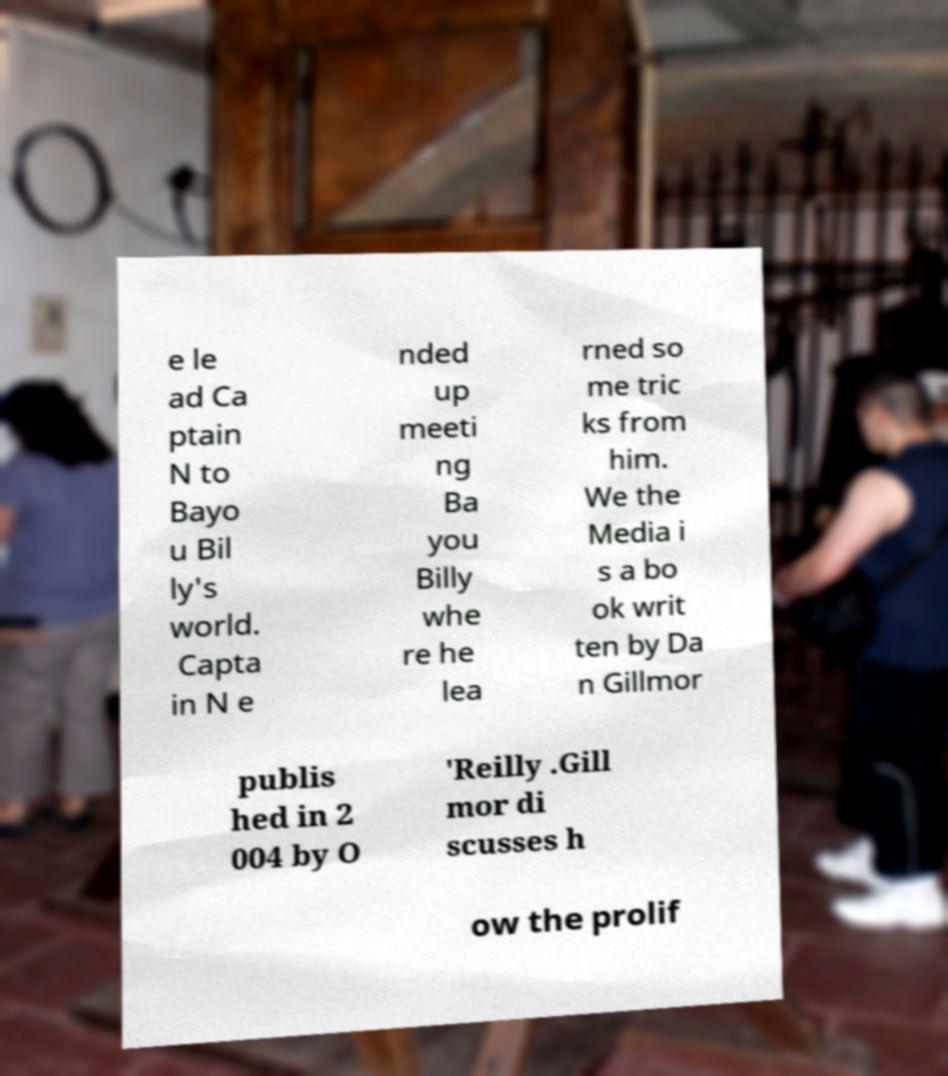Please identify and transcribe the text found in this image. e le ad Ca ptain N to Bayo u Bil ly's world. Capta in N e nded up meeti ng Ba you Billy whe re he lea rned so me tric ks from him. We the Media i s a bo ok writ ten by Da n Gillmor publis hed in 2 004 by O 'Reilly .Gill mor di scusses h ow the prolif 